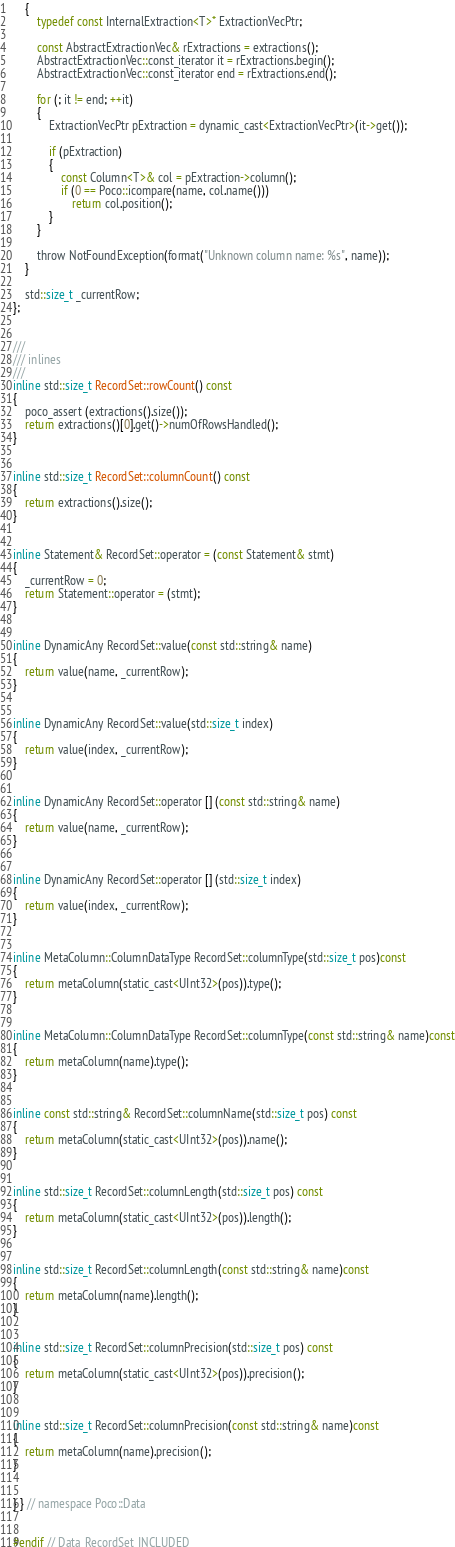<code> <loc_0><loc_0><loc_500><loc_500><_C_>	{
		typedef const InternalExtraction<T>* ExtractionVecPtr;

		const AbstractExtractionVec& rExtractions = extractions();
		AbstractExtractionVec::const_iterator it = rExtractions.begin();
		AbstractExtractionVec::const_iterator end = rExtractions.end();
		
		for (; it != end; ++it)
		{
			ExtractionVecPtr pExtraction = dynamic_cast<ExtractionVecPtr>(it->get());

			if (pExtraction)
			{
				const Column<T>& col = pExtraction->column();
				if (0 == Poco::icompare(name, col.name()))
					return col.position();
			}
		}

		throw NotFoundException(format("Unknown column name: %s", name));
	}

	std::size_t _currentRow;
};


///
/// inlines
///
inline std::size_t RecordSet::rowCount() const
{
	poco_assert (extractions().size());
	return extractions()[0].get()->numOfRowsHandled();
}


inline std::size_t RecordSet::columnCount() const
{
	return extractions().size();
}


inline Statement& RecordSet::operator = (const Statement& stmt)
{
	_currentRow = 0;
	return Statement::operator = (stmt);
}


inline DynamicAny RecordSet::value(const std::string& name)
{
	return value(name, _currentRow);
}


inline DynamicAny RecordSet::value(std::size_t index)
{
	return value(index, _currentRow);
}


inline DynamicAny RecordSet::operator [] (const std::string& name)
{
	return value(name, _currentRow);
}


inline DynamicAny RecordSet::operator [] (std::size_t index)
{
	return value(index, _currentRow);
}


inline MetaColumn::ColumnDataType RecordSet::columnType(std::size_t pos)const
{
	return metaColumn(static_cast<UInt32>(pos)).type();
}


inline MetaColumn::ColumnDataType RecordSet::columnType(const std::string& name)const
{
	return metaColumn(name).type();
}


inline const std::string& RecordSet::columnName(std::size_t pos) const
{
	return metaColumn(static_cast<UInt32>(pos)).name();
}


inline std::size_t RecordSet::columnLength(std::size_t pos) const
{
	return metaColumn(static_cast<UInt32>(pos)).length();
}


inline std::size_t RecordSet::columnLength(const std::string& name)const
{
	return metaColumn(name).length();
}


inline std::size_t RecordSet::columnPrecision(std::size_t pos) const
{
	return metaColumn(static_cast<UInt32>(pos)).precision();
}


inline std::size_t RecordSet::columnPrecision(const std::string& name)const
{
	return metaColumn(name).precision();
}


} } // namespace Poco::Data


#endif // Data_RecordSet_INCLUDED
</code> 